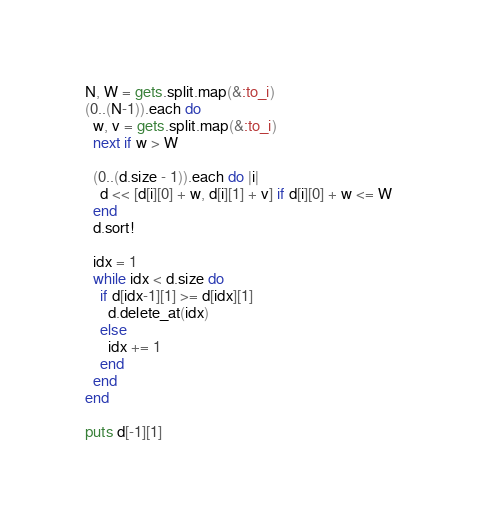<code> <loc_0><loc_0><loc_500><loc_500><_Ruby_>N, W = gets.split.map(&:to_i)
(0..(N-1)).each do
  w, v = gets.split.map(&:to_i)
  next if w > W
  
  (0..(d.size - 1)).each do |i|
    d << [d[i][0] + w, d[i][1] + v] if d[i][0] + w <= W
  end
  d.sort!
  
  idx = 1
  while idx < d.size do
    if d[idx-1][1] >= d[idx][1]
      d.delete_at(idx)
    else
      idx += 1
    end
  end
end

puts d[-1][1]</code> 